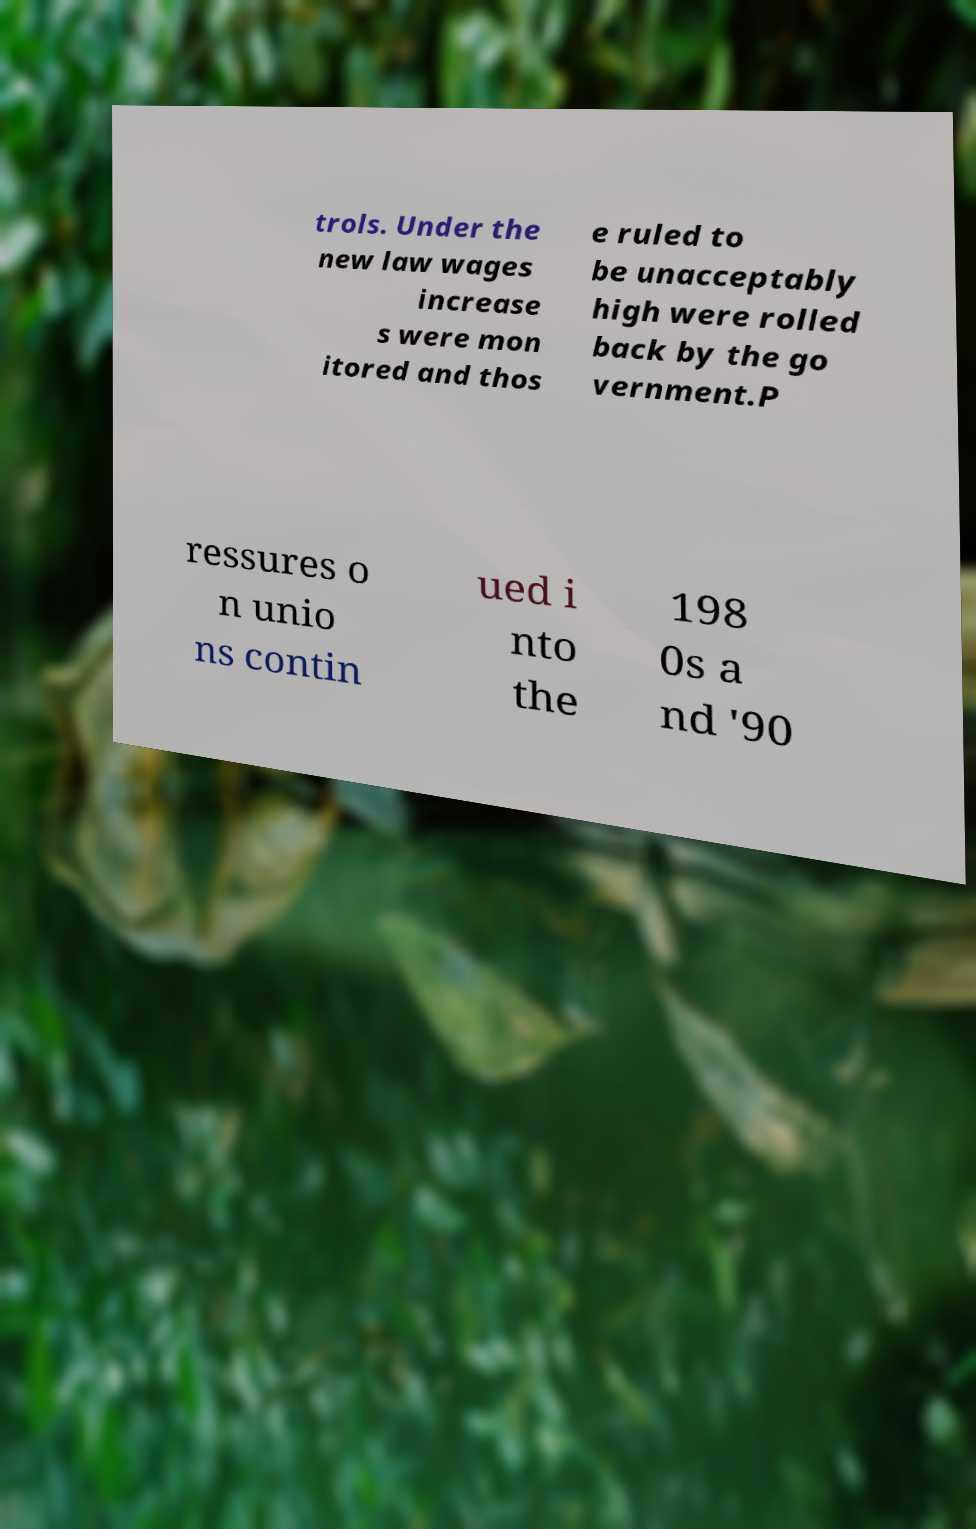Could you assist in decoding the text presented in this image and type it out clearly? trols. Under the new law wages increase s were mon itored and thos e ruled to be unacceptably high were rolled back by the go vernment.P ressures o n unio ns contin ued i nto the 198 0s a nd '90 